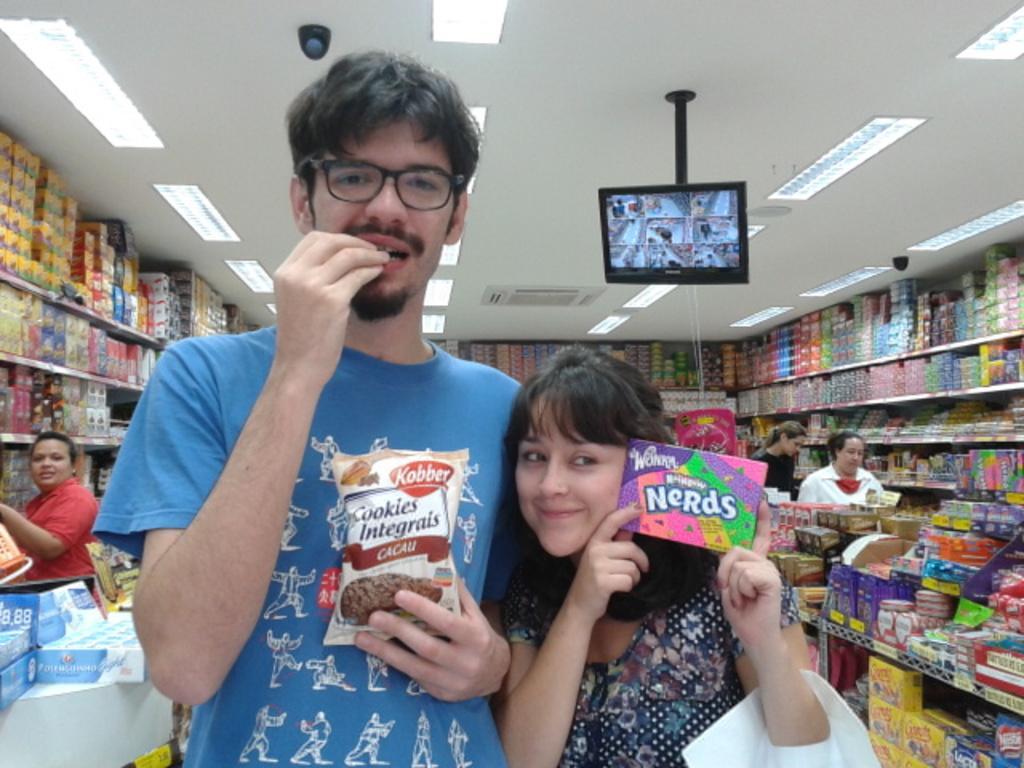Could you give a brief overview of what you see in this image? In front of the image there is a person holding a bag of cookies is eating, beside the person there is a girl holding a box, behind them there are a few people and there are a few objects on the aisles of a store, at the top of the image there is a monitor with a rod and a camera and there are lights. 